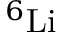<formula> <loc_0><loc_0><loc_500><loc_500>^ { 6 } L i</formula> 